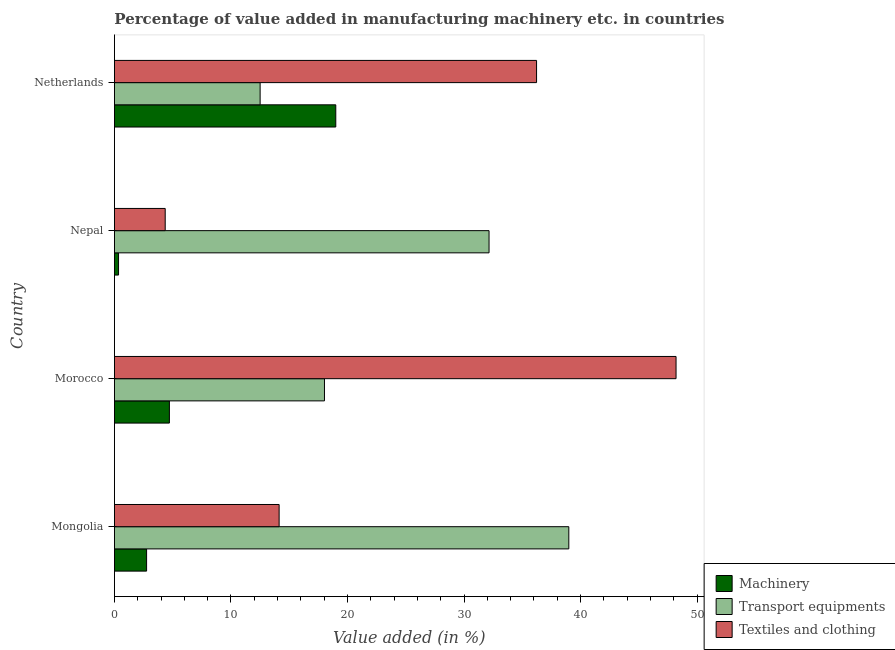How many bars are there on the 3rd tick from the top?
Provide a succinct answer. 3. What is the label of the 4th group of bars from the top?
Ensure brevity in your answer.  Mongolia. What is the value added in manufacturing textile and clothing in Morocco?
Your answer should be very brief. 48.19. Across all countries, what is the maximum value added in manufacturing textile and clothing?
Offer a very short reply. 48.19. Across all countries, what is the minimum value added in manufacturing machinery?
Offer a terse response. 0.35. In which country was the value added in manufacturing textile and clothing maximum?
Offer a very short reply. Morocco. In which country was the value added in manufacturing textile and clothing minimum?
Your answer should be very brief. Nepal. What is the total value added in manufacturing machinery in the graph?
Your response must be concise. 26.82. What is the difference between the value added in manufacturing machinery in Mongolia and that in Nepal?
Make the answer very short. 2.41. What is the difference between the value added in manufacturing machinery in Morocco and the value added in manufacturing transport equipments in Nepal?
Provide a short and direct response. -27.43. What is the average value added in manufacturing transport equipments per country?
Your answer should be very brief. 25.42. What is the difference between the value added in manufacturing transport equipments and value added in manufacturing textile and clothing in Nepal?
Ensure brevity in your answer.  27.79. In how many countries, is the value added in manufacturing transport equipments greater than 10 %?
Provide a succinct answer. 4. What is the ratio of the value added in manufacturing transport equipments in Mongolia to that in Nepal?
Offer a terse response. 1.21. Is the value added in manufacturing machinery in Morocco less than that in Netherlands?
Keep it short and to the point. Yes. Is the difference between the value added in manufacturing textile and clothing in Mongolia and Morocco greater than the difference between the value added in manufacturing machinery in Mongolia and Morocco?
Give a very brief answer. No. What is the difference between the highest and the second highest value added in manufacturing textile and clothing?
Provide a short and direct response. 11.97. What is the difference between the highest and the lowest value added in manufacturing transport equipments?
Offer a very short reply. 26.49. What does the 1st bar from the top in Mongolia represents?
Your answer should be compact. Textiles and clothing. What does the 1st bar from the bottom in Nepal represents?
Provide a short and direct response. Machinery. How many bars are there?
Provide a succinct answer. 12. How many countries are there in the graph?
Offer a terse response. 4. Does the graph contain grids?
Ensure brevity in your answer.  No. Where does the legend appear in the graph?
Your answer should be compact. Bottom right. What is the title of the graph?
Offer a terse response. Percentage of value added in manufacturing machinery etc. in countries. What is the label or title of the X-axis?
Your response must be concise. Value added (in %). What is the label or title of the Y-axis?
Your answer should be compact. Country. What is the Value added (in %) in Machinery in Mongolia?
Keep it short and to the point. 2.76. What is the Value added (in %) in Transport equipments in Mongolia?
Provide a short and direct response. 38.99. What is the Value added (in %) in Textiles and clothing in Mongolia?
Your response must be concise. 14.13. What is the Value added (in %) in Machinery in Morocco?
Provide a short and direct response. 4.72. What is the Value added (in %) of Transport equipments in Morocco?
Your answer should be compact. 18.02. What is the Value added (in %) of Textiles and clothing in Morocco?
Offer a terse response. 48.19. What is the Value added (in %) in Machinery in Nepal?
Keep it short and to the point. 0.35. What is the Value added (in %) in Transport equipments in Nepal?
Offer a terse response. 32.15. What is the Value added (in %) in Textiles and clothing in Nepal?
Offer a very short reply. 4.36. What is the Value added (in %) in Machinery in Netherlands?
Your answer should be very brief. 18.99. What is the Value added (in %) of Transport equipments in Netherlands?
Your answer should be very brief. 12.5. What is the Value added (in %) of Textiles and clothing in Netherlands?
Ensure brevity in your answer.  36.22. Across all countries, what is the maximum Value added (in %) of Machinery?
Your answer should be very brief. 18.99. Across all countries, what is the maximum Value added (in %) in Transport equipments?
Offer a very short reply. 38.99. Across all countries, what is the maximum Value added (in %) of Textiles and clothing?
Provide a short and direct response. 48.19. Across all countries, what is the minimum Value added (in %) in Machinery?
Provide a succinct answer. 0.35. Across all countries, what is the minimum Value added (in %) of Transport equipments?
Make the answer very short. 12.5. Across all countries, what is the minimum Value added (in %) of Textiles and clothing?
Offer a terse response. 4.36. What is the total Value added (in %) in Machinery in the graph?
Offer a very short reply. 26.82. What is the total Value added (in %) in Transport equipments in the graph?
Offer a terse response. 101.66. What is the total Value added (in %) in Textiles and clothing in the graph?
Make the answer very short. 102.91. What is the difference between the Value added (in %) in Machinery in Mongolia and that in Morocco?
Offer a very short reply. -1.96. What is the difference between the Value added (in %) in Transport equipments in Mongolia and that in Morocco?
Keep it short and to the point. 20.97. What is the difference between the Value added (in %) in Textiles and clothing in Mongolia and that in Morocco?
Your answer should be very brief. -34.06. What is the difference between the Value added (in %) of Machinery in Mongolia and that in Nepal?
Offer a terse response. 2.41. What is the difference between the Value added (in %) of Transport equipments in Mongolia and that in Nepal?
Your answer should be very brief. 6.84. What is the difference between the Value added (in %) of Textiles and clothing in Mongolia and that in Nepal?
Your answer should be very brief. 9.78. What is the difference between the Value added (in %) in Machinery in Mongolia and that in Netherlands?
Make the answer very short. -16.23. What is the difference between the Value added (in %) of Transport equipments in Mongolia and that in Netherlands?
Provide a short and direct response. 26.49. What is the difference between the Value added (in %) in Textiles and clothing in Mongolia and that in Netherlands?
Provide a succinct answer. -22.09. What is the difference between the Value added (in %) in Machinery in Morocco and that in Nepal?
Ensure brevity in your answer.  4.36. What is the difference between the Value added (in %) in Transport equipments in Morocco and that in Nepal?
Your answer should be compact. -14.12. What is the difference between the Value added (in %) of Textiles and clothing in Morocco and that in Nepal?
Provide a short and direct response. 43.84. What is the difference between the Value added (in %) in Machinery in Morocco and that in Netherlands?
Provide a succinct answer. -14.28. What is the difference between the Value added (in %) in Transport equipments in Morocco and that in Netherlands?
Provide a short and direct response. 5.52. What is the difference between the Value added (in %) in Textiles and clothing in Morocco and that in Netherlands?
Your answer should be very brief. 11.97. What is the difference between the Value added (in %) in Machinery in Nepal and that in Netherlands?
Your answer should be very brief. -18.64. What is the difference between the Value added (in %) in Transport equipments in Nepal and that in Netherlands?
Provide a short and direct response. 19.64. What is the difference between the Value added (in %) of Textiles and clothing in Nepal and that in Netherlands?
Offer a very short reply. -31.87. What is the difference between the Value added (in %) of Machinery in Mongolia and the Value added (in %) of Transport equipments in Morocco?
Your answer should be compact. -15.26. What is the difference between the Value added (in %) in Machinery in Mongolia and the Value added (in %) in Textiles and clothing in Morocco?
Give a very brief answer. -45.43. What is the difference between the Value added (in %) of Transport equipments in Mongolia and the Value added (in %) of Textiles and clothing in Morocco?
Your answer should be compact. -9.2. What is the difference between the Value added (in %) of Machinery in Mongolia and the Value added (in %) of Transport equipments in Nepal?
Provide a short and direct response. -29.39. What is the difference between the Value added (in %) in Machinery in Mongolia and the Value added (in %) in Textiles and clothing in Nepal?
Keep it short and to the point. -1.6. What is the difference between the Value added (in %) in Transport equipments in Mongolia and the Value added (in %) in Textiles and clothing in Nepal?
Ensure brevity in your answer.  34.63. What is the difference between the Value added (in %) of Machinery in Mongolia and the Value added (in %) of Transport equipments in Netherlands?
Ensure brevity in your answer.  -9.74. What is the difference between the Value added (in %) in Machinery in Mongolia and the Value added (in %) in Textiles and clothing in Netherlands?
Ensure brevity in your answer.  -33.46. What is the difference between the Value added (in %) of Transport equipments in Mongolia and the Value added (in %) of Textiles and clothing in Netherlands?
Provide a short and direct response. 2.77. What is the difference between the Value added (in %) in Machinery in Morocco and the Value added (in %) in Transport equipments in Nepal?
Make the answer very short. -27.43. What is the difference between the Value added (in %) in Machinery in Morocco and the Value added (in %) in Textiles and clothing in Nepal?
Provide a short and direct response. 0.36. What is the difference between the Value added (in %) in Transport equipments in Morocco and the Value added (in %) in Textiles and clothing in Nepal?
Your response must be concise. 13.67. What is the difference between the Value added (in %) of Machinery in Morocco and the Value added (in %) of Transport equipments in Netherlands?
Ensure brevity in your answer.  -7.79. What is the difference between the Value added (in %) in Machinery in Morocco and the Value added (in %) in Textiles and clothing in Netherlands?
Your response must be concise. -31.51. What is the difference between the Value added (in %) of Transport equipments in Morocco and the Value added (in %) of Textiles and clothing in Netherlands?
Your answer should be very brief. -18.2. What is the difference between the Value added (in %) in Machinery in Nepal and the Value added (in %) in Transport equipments in Netherlands?
Offer a very short reply. -12.15. What is the difference between the Value added (in %) of Machinery in Nepal and the Value added (in %) of Textiles and clothing in Netherlands?
Give a very brief answer. -35.87. What is the difference between the Value added (in %) in Transport equipments in Nepal and the Value added (in %) in Textiles and clothing in Netherlands?
Your answer should be very brief. -4.08. What is the average Value added (in %) in Machinery per country?
Ensure brevity in your answer.  6.71. What is the average Value added (in %) of Transport equipments per country?
Provide a short and direct response. 25.42. What is the average Value added (in %) in Textiles and clothing per country?
Provide a short and direct response. 25.73. What is the difference between the Value added (in %) in Machinery and Value added (in %) in Transport equipments in Mongolia?
Make the answer very short. -36.23. What is the difference between the Value added (in %) of Machinery and Value added (in %) of Textiles and clothing in Mongolia?
Keep it short and to the point. -11.37. What is the difference between the Value added (in %) of Transport equipments and Value added (in %) of Textiles and clothing in Mongolia?
Give a very brief answer. 24.86. What is the difference between the Value added (in %) in Machinery and Value added (in %) in Transport equipments in Morocco?
Your response must be concise. -13.31. What is the difference between the Value added (in %) in Machinery and Value added (in %) in Textiles and clothing in Morocco?
Give a very brief answer. -43.48. What is the difference between the Value added (in %) of Transport equipments and Value added (in %) of Textiles and clothing in Morocco?
Make the answer very short. -30.17. What is the difference between the Value added (in %) of Machinery and Value added (in %) of Transport equipments in Nepal?
Provide a succinct answer. -31.79. What is the difference between the Value added (in %) of Machinery and Value added (in %) of Textiles and clothing in Nepal?
Provide a short and direct response. -4. What is the difference between the Value added (in %) in Transport equipments and Value added (in %) in Textiles and clothing in Nepal?
Your answer should be compact. 27.79. What is the difference between the Value added (in %) in Machinery and Value added (in %) in Transport equipments in Netherlands?
Give a very brief answer. 6.49. What is the difference between the Value added (in %) in Machinery and Value added (in %) in Textiles and clothing in Netherlands?
Give a very brief answer. -17.23. What is the difference between the Value added (in %) in Transport equipments and Value added (in %) in Textiles and clothing in Netherlands?
Offer a very short reply. -23.72. What is the ratio of the Value added (in %) of Machinery in Mongolia to that in Morocco?
Offer a very short reply. 0.59. What is the ratio of the Value added (in %) of Transport equipments in Mongolia to that in Morocco?
Your answer should be very brief. 2.16. What is the ratio of the Value added (in %) of Textiles and clothing in Mongolia to that in Morocco?
Your answer should be very brief. 0.29. What is the ratio of the Value added (in %) of Machinery in Mongolia to that in Nepal?
Offer a very short reply. 7.8. What is the ratio of the Value added (in %) of Transport equipments in Mongolia to that in Nepal?
Keep it short and to the point. 1.21. What is the ratio of the Value added (in %) of Textiles and clothing in Mongolia to that in Nepal?
Offer a terse response. 3.24. What is the ratio of the Value added (in %) of Machinery in Mongolia to that in Netherlands?
Provide a short and direct response. 0.15. What is the ratio of the Value added (in %) of Transport equipments in Mongolia to that in Netherlands?
Provide a short and direct response. 3.12. What is the ratio of the Value added (in %) of Textiles and clothing in Mongolia to that in Netherlands?
Provide a succinct answer. 0.39. What is the ratio of the Value added (in %) in Machinery in Morocco to that in Nepal?
Provide a succinct answer. 13.33. What is the ratio of the Value added (in %) in Transport equipments in Morocco to that in Nepal?
Your answer should be compact. 0.56. What is the ratio of the Value added (in %) in Textiles and clothing in Morocco to that in Nepal?
Offer a very short reply. 11.06. What is the ratio of the Value added (in %) of Machinery in Morocco to that in Netherlands?
Make the answer very short. 0.25. What is the ratio of the Value added (in %) of Transport equipments in Morocco to that in Netherlands?
Your response must be concise. 1.44. What is the ratio of the Value added (in %) of Textiles and clothing in Morocco to that in Netherlands?
Ensure brevity in your answer.  1.33. What is the ratio of the Value added (in %) of Machinery in Nepal to that in Netherlands?
Offer a very short reply. 0.02. What is the ratio of the Value added (in %) of Transport equipments in Nepal to that in Netherlands?
Offer a very short reply. 2.57. What is the ratio of the Value added (in %) of Textiles and clothing in Nepal to that in Netherlands?
Offer a very short reply. 0.12. What is the difference between the highest and the second highest Value added (in %) in Machinery?
Your response must be concise. 14.28. What is the difference between the highest and the second highest Value added (in %) of Transport equipments?
Make the answer very short. 6.84. What is the difference between the highest and the second highest Value added (in %) of Textiles and clothing?
Ensure brevity in your answer.  11.97. What is the difference between the highest and the lowest Value added (in %) of Machinery?
Your response must be concise. 18.64. What is the difference between the highest and the lowest Value added (in %) of Transport equipments?
Provide a succinct answer. 26.49. What is the difference between the highest and the lowest Value added (in %) of Textiles and clothing?
Offer a terse response. 43.84. 